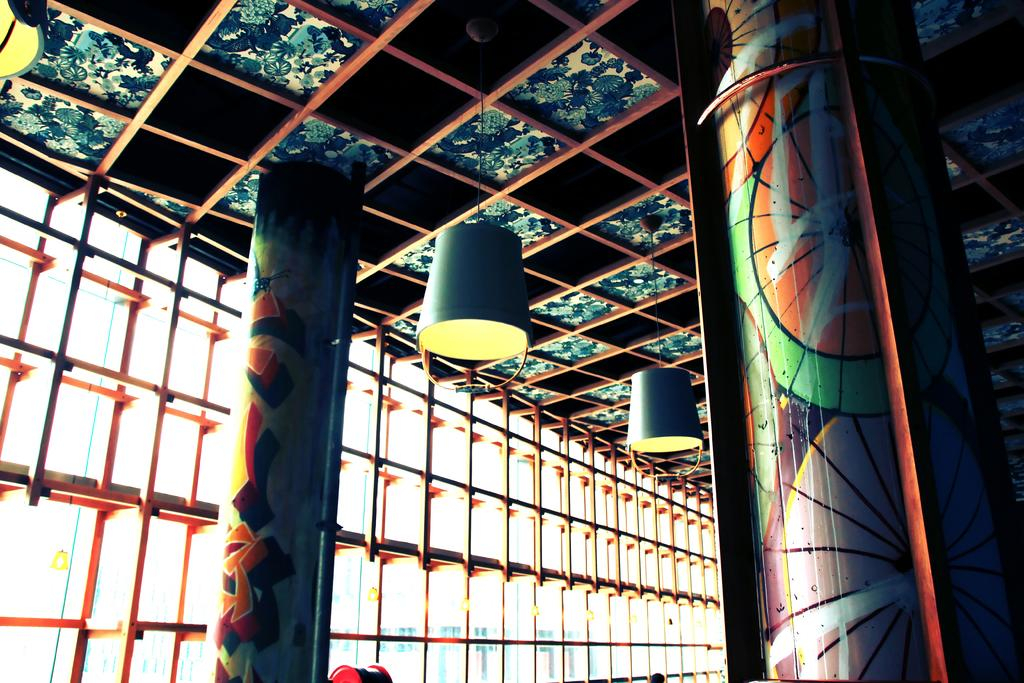What architectural features can be seen in the image? There are windows and pillars in the image. What structure is located at the top of the image? There is a shed at the top of the image. What type of lighting is present in the image? Lights are hanging in the image. What type of office can be seen in the image? There is no office present in the image; it features windows, pillars, a shed, and hanging lights. What shape is the square in the image? There is no square present in the image. 